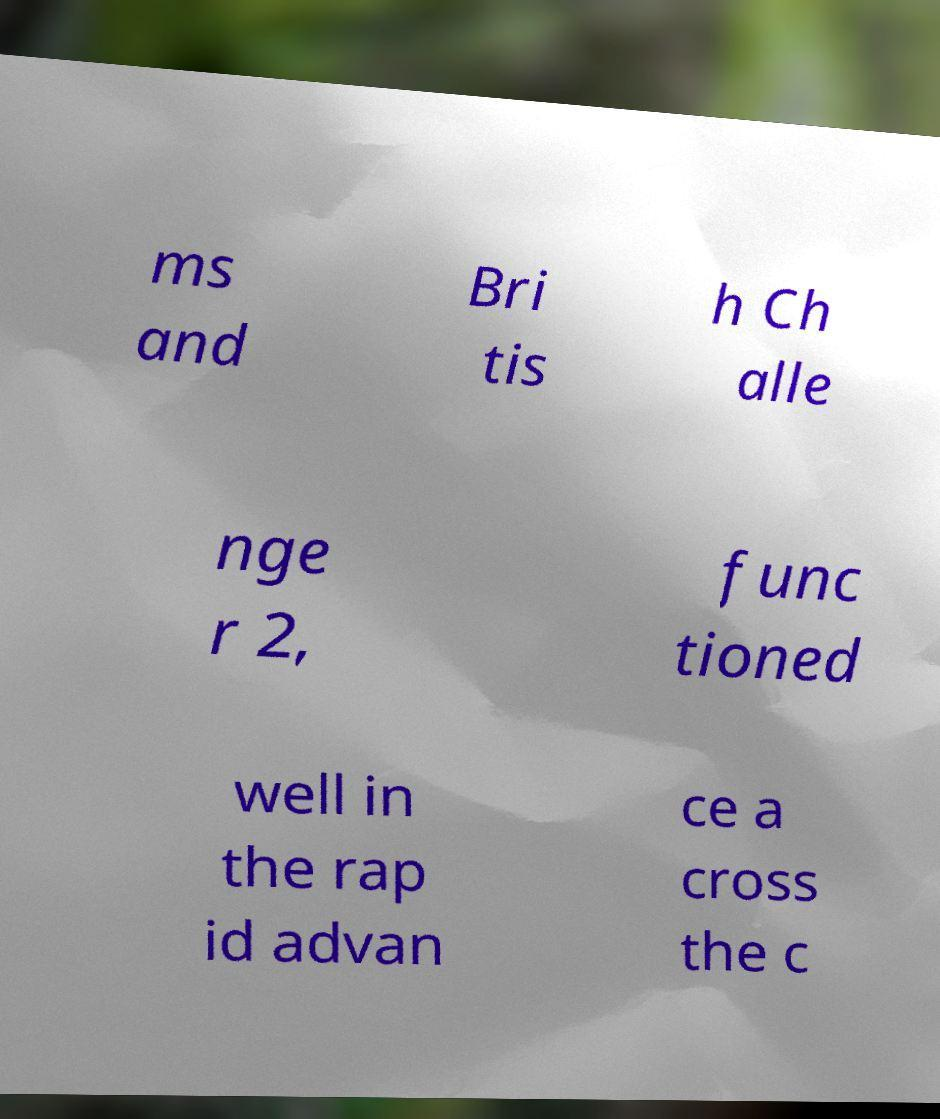Can you accurately transcribe the text from the provided image for me? ms and Bri tis h Ch alle nge r 2, func tioned well in the rap id advan ce a cross the c 